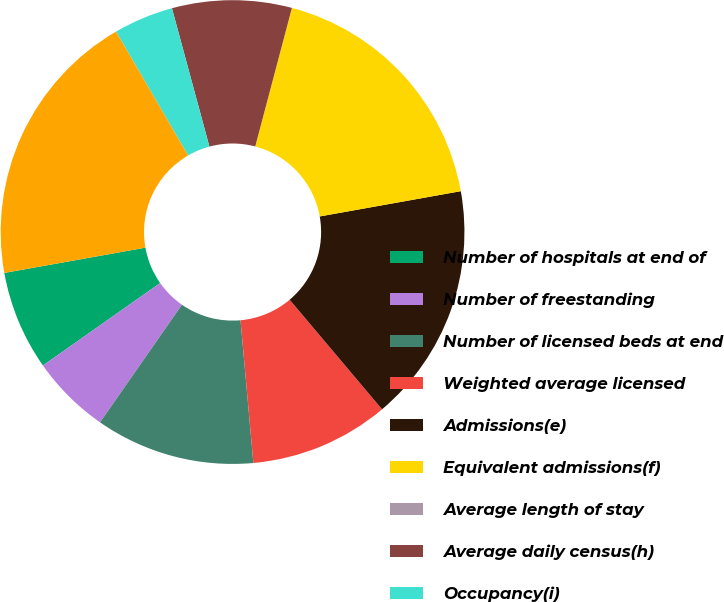Convert chart. <chart><loc_0><loc_0><loc_500><loc_500><pie_chart><fcel>Number of hospitals at end of<fcel>Number of freestanding<fcel>Number of licensed beds at end<fcel>Weighted average licensed<fcel>Admissions(e)<fcel>Equivalent admissions(f)<fcel>Average length of stay<fcel>Average daily census(h)<fcel>Occupancy(i)<fcel>Emergency room visits(j)<nl><fcel>6.94%<fcel>5.56%<fcel>11.11%<fcel>9.72%<fcel>16.67%<fcel>18.06%<fcel>0.0%<fcel>8.33%<fcel>4.17%<fcel>19.44%<nl></chart> 